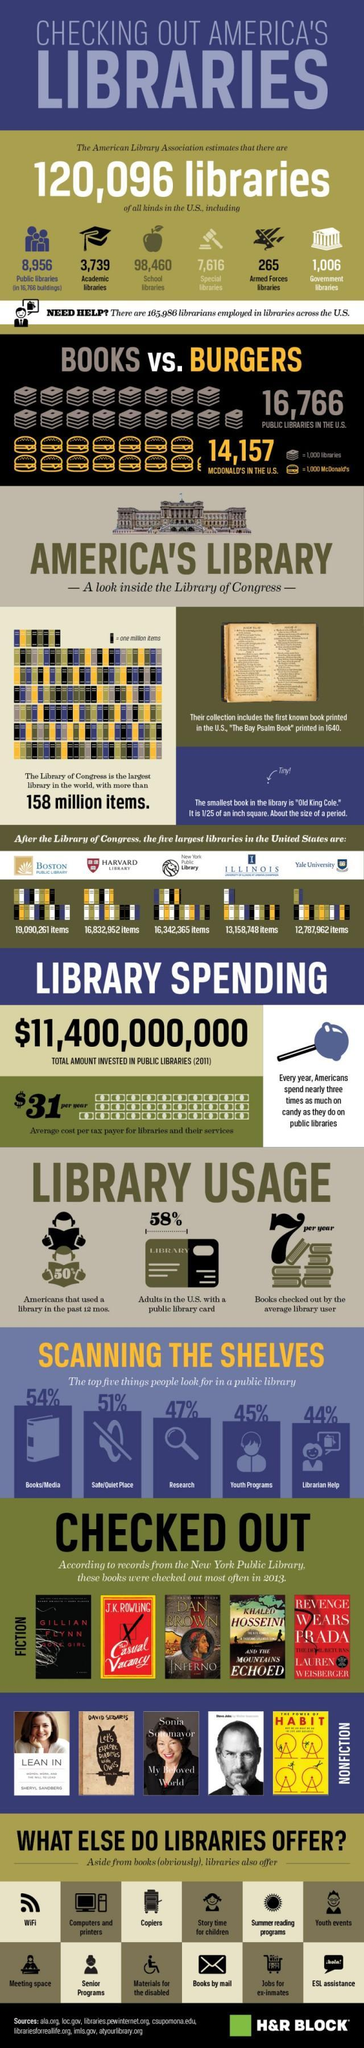what is the total number of academic libraries and school libraries?
Answer the question with a short phrase. 102199 Which is the third largest library in the US? Harvard library Which is more - number of public libraries or  Mc Donald's in the US? public libraries which library service is been represented by the symbol of sun in this infographic? summer reading programs what is the second most considerable thing people look for in a public library? safe/quiet place Which is the second largest library in the US? Boston public library which book is given first in the list of nonfiction books that were checked out most often in 2013? lean in Which is the fourth largest library in the US? New York public library How many services offered by libraries apart from books are given in this infographic? 12 What is the total number of public libraries and government libraries? 9962 